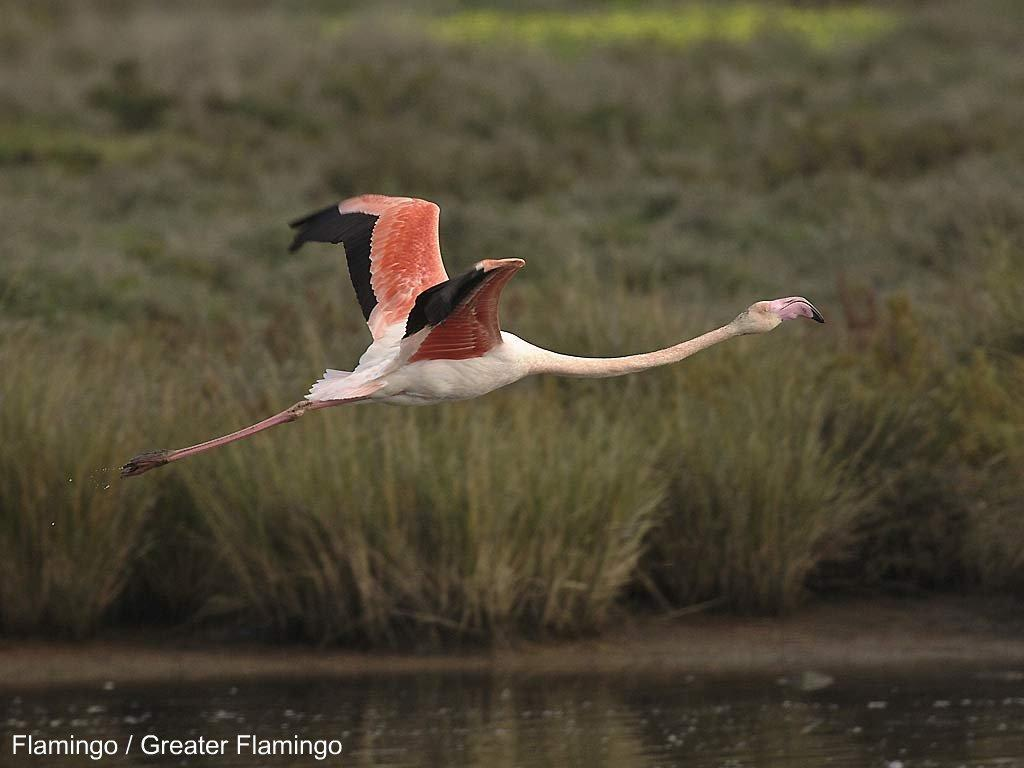What is the bird doing in the image? The bird is flying in the air. What type of vegetation can be seen in the image? There are bushes in the image. What natural element is visible in the image? Water is visible in the image. How many hours of sleep does the bird need in the image? The image does not provide information about the bird's sleep habits, so it cannot be determined. 